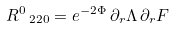<formula> <loc_0><loc_0><loc_500><loc_500>R ^ { 0 } \, _ { 2 2 0 } = e ^ { - 2 \Phi } \, \partial _ { r } \Lambda \, \partial _ { r } F</formula> 